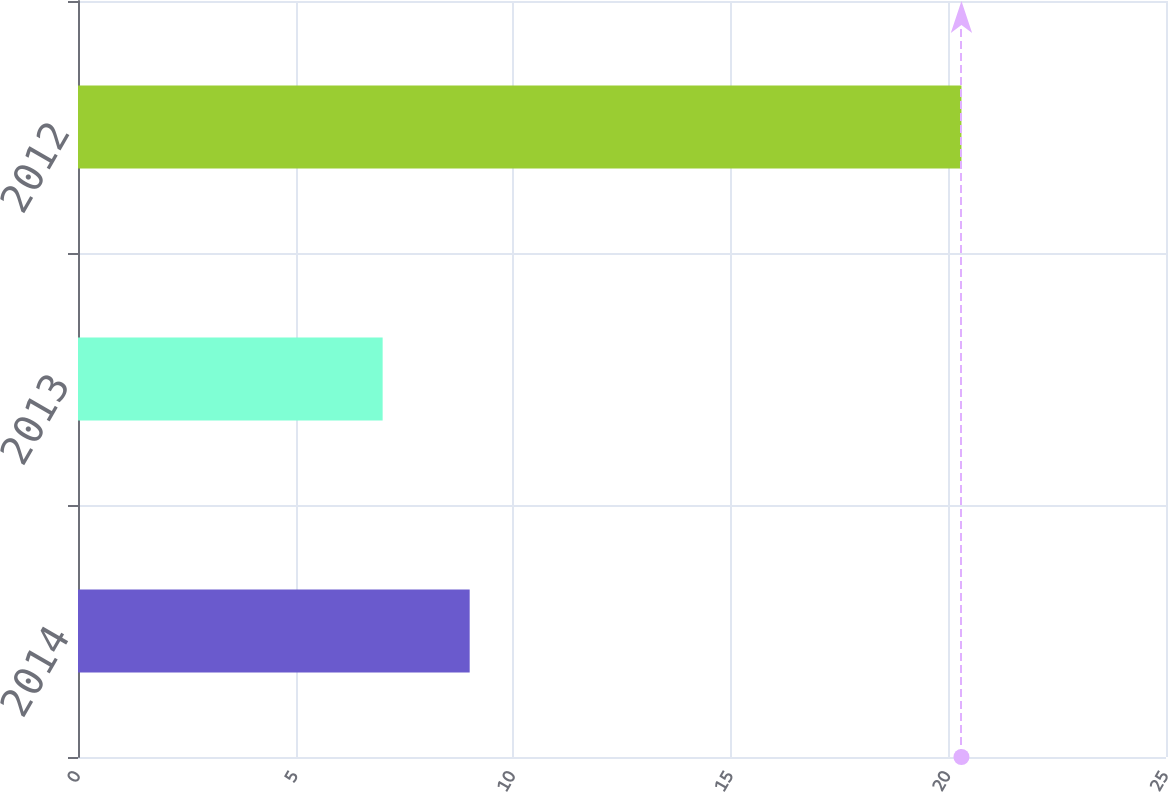<chart> <loc_0><loc_0><loc_500><loc_500><bar_chart><fcel>2014<fcel>2013<fcel>2012<nl><fcel>9<fcel>7<fcel>20.3<nl></chart> 